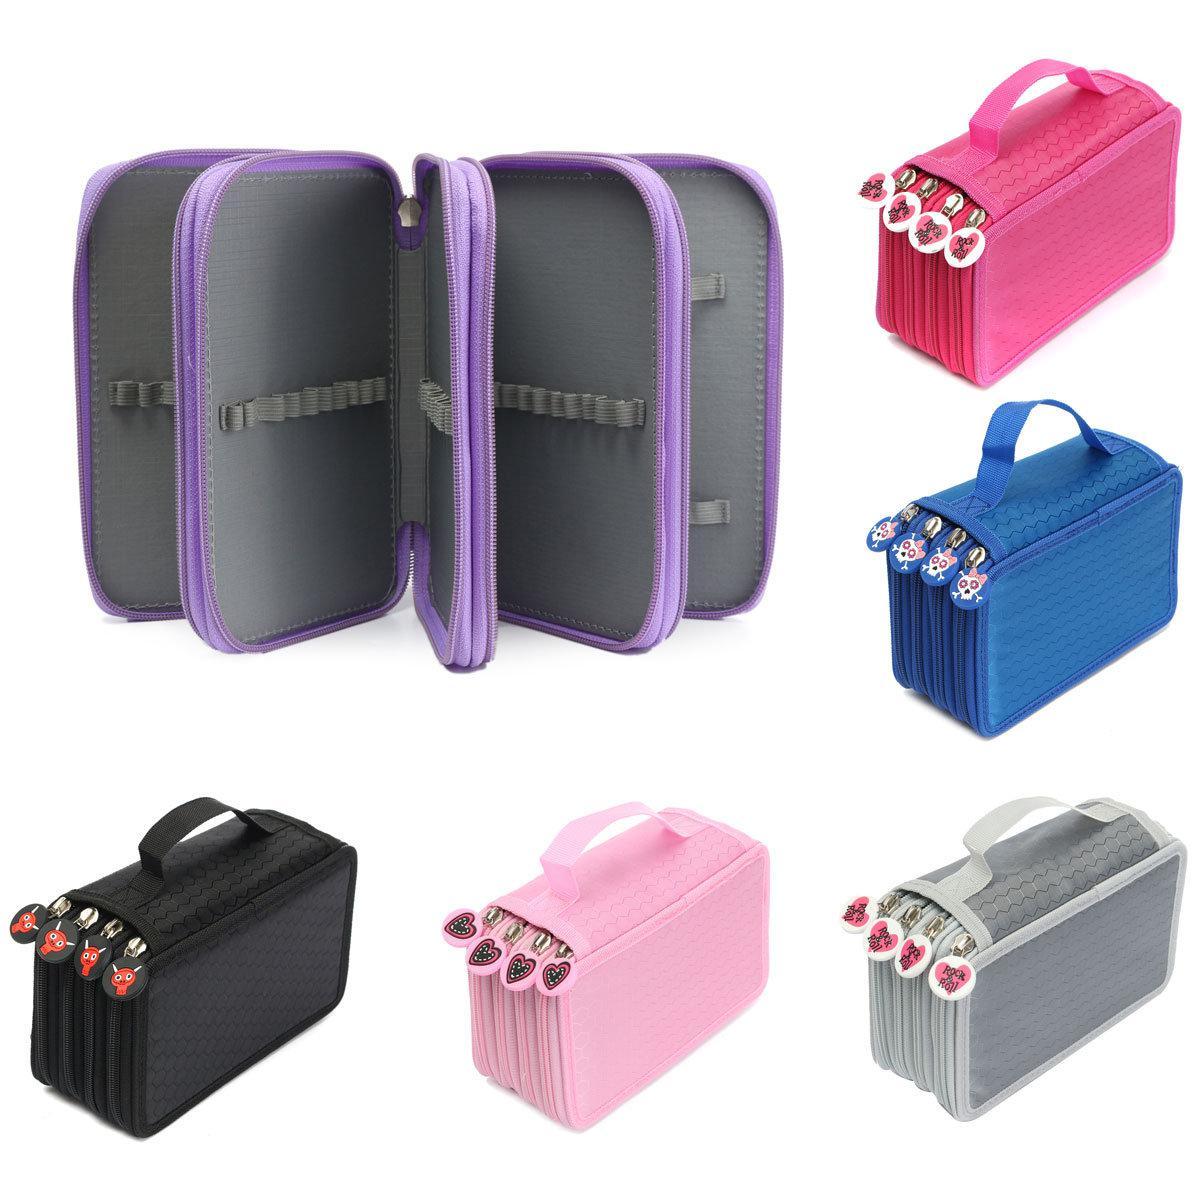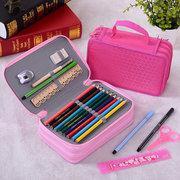The first image is the image on the left, the second image is the image on the right. Given the left and right images, does the statement "The left image shows exactly one case." hold true? Answer yes or no. No. The first image is the image on the left, the second image is the image on the right. For the images shown, is this caption "At least one image contains a single pencil case." true? Answer yes or no. No. The first image is the image on the left, the second image is the image on the right. Given the left and right images, does the statement "There is an image that has an open and a closed case" hold true? Answer yes or no. Yes. 